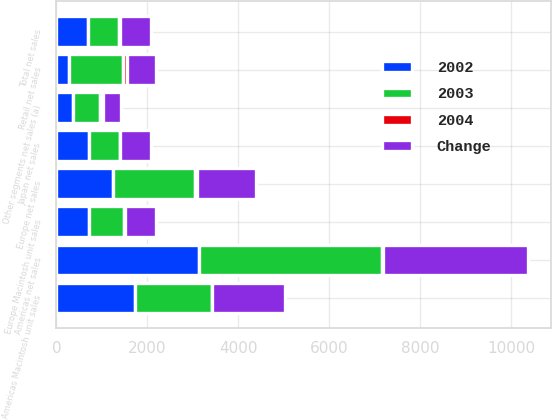<chart> <loc_0><loc_0><loc_500><loc_500><stacked_bar_chart><ecel><fcel>Americas net sales<fcel>Europe net sales<fcel>Japan net sales<fcel>Retail net sales<fcel>Other segments net sales (a)<fcel>Total net sales<fcel>Americas Macintosh unit sales<fcel>Europe Macintosh unit sales<nl><fcel>2003<fcel>4019<fcel>1799<fcel>677<fcel>1185<fcel>599<fcel>684<fcel>1682<fcel>773<nl><fcel>2004<fcel>26<fcel>37<fcel>3<fcel>91<fcel>51<fcel>33<fcel>4<fcel>13<nl><fcel>Change<fcel>3181<fcel>1309<fcel>698<fcel>621<fcel>398<fcel>684<fcel>1620<fcel>684<nl><fcel>2002<fcel>3131<fcel>1251<fcel>710<fcel>283<fcel>367<fcel>684<fcel>1728<fcel>722<nl></chart> 